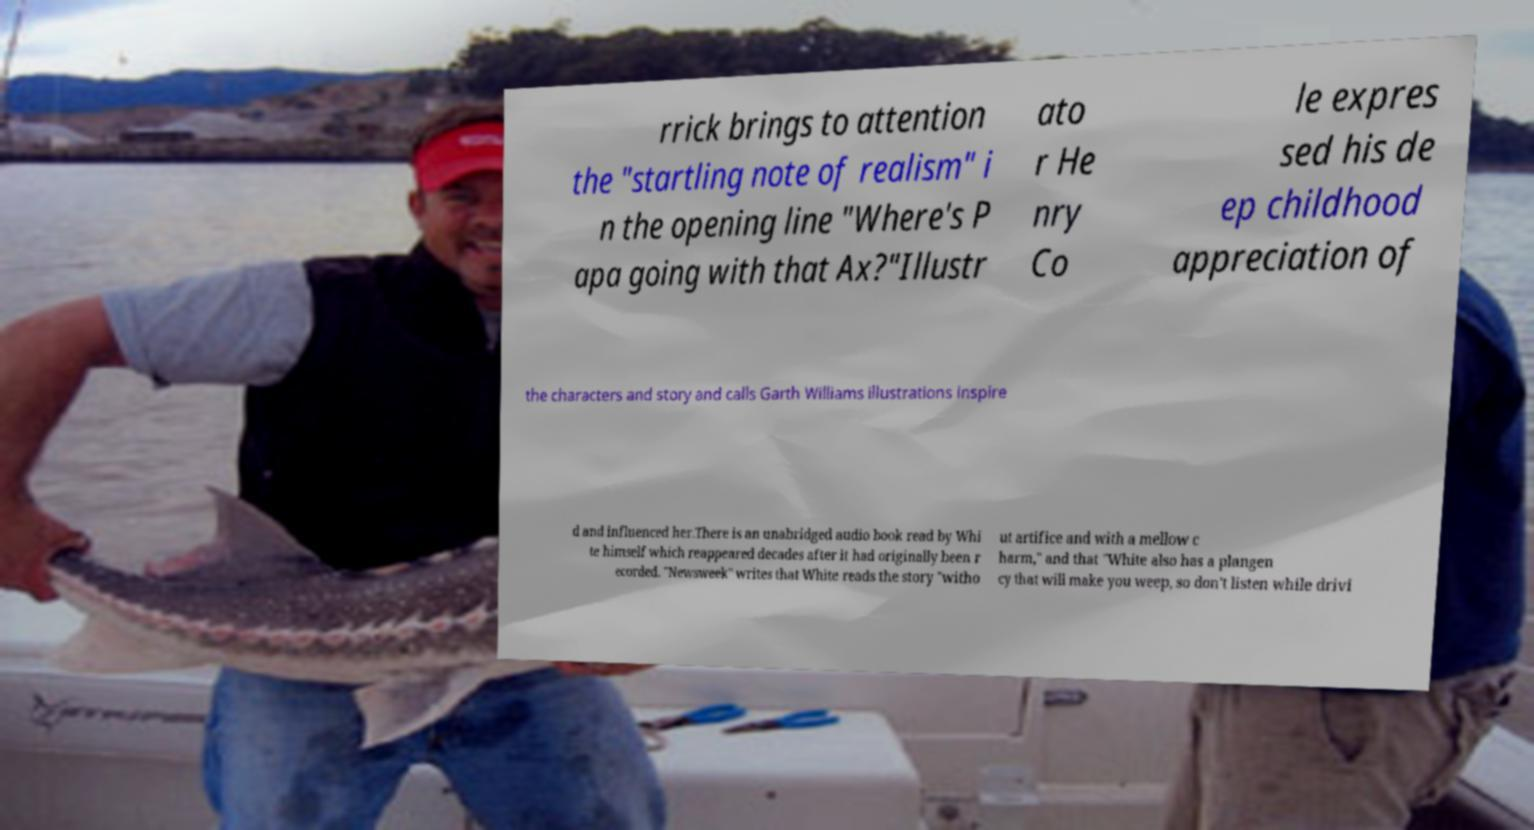Please identify and transcribe the text found in this image. rrick brings to attention the "startling note of realism" i n the opening line "Where's P apa going with that Ax?"Illustr ato r He nry Co le expres sed his de ep childhood appreciation of the characters and story and calls Garth Williams illustrations inspire d and influenced her.There is an unabridged audio book read by Whi te himself which reappeared decades after it had originally been r ecorded. "Newsweek" writes that White reads the story "witho ut artifice and with a mellow c harm," and that "White also has a plangen cy that will make you weep, so don't listen while drivi 